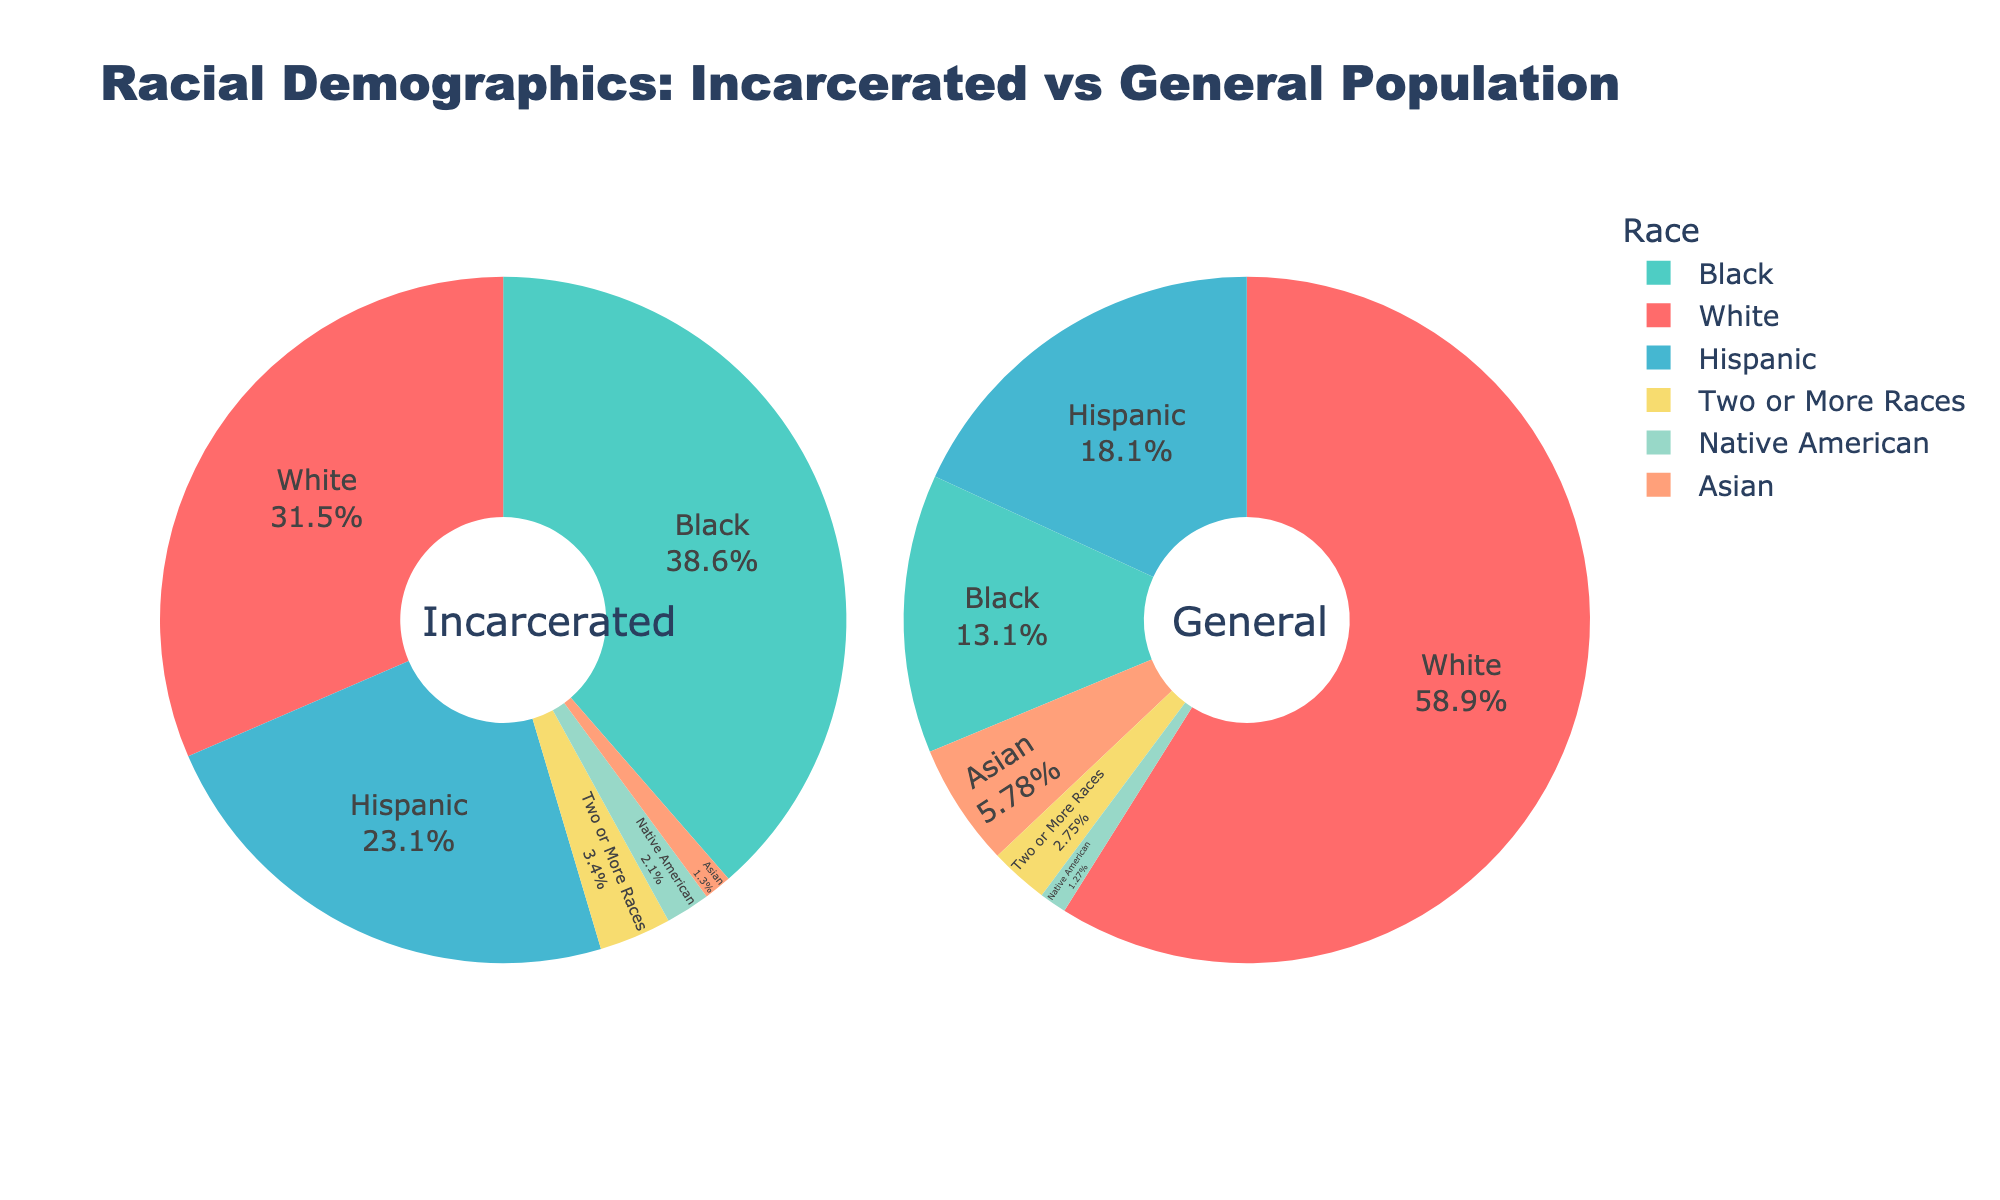Incarcerated Population which racial group has the highest percentage? Observing the pie chart of the Incarcerated Population, the Black racial group's segment occupies the largest area.
Answer: Black Incarcerated Population vs General Population, which race is most overrepresented in incarceration? By comparing the two pie charts, the Black racial group is significantly larger in the Incarcerated Population chart (38.6%) compared to its representation in the General Population (13.4%).
Answer: Black What's the overall difference in representation between the White racial group in the General Population and Incarcerated Population? Subtracting the percentage of the White racial group in the Incarcerated Population (31.5%) from their percentage in the General Population (60.1%) gives 28.6%.
Answer: 28.6% What is the sum of the percentages of Hispanic and Asian groups in the Incarcerated Population? Adding the percentage of the Hispanic group (23.1%) with the percentage of the Asian group (1.3%) in the Incarcerated Population chart results in 24.4%.
Answer: 24.4% How many racial groups have a higher percentage in the General Population than in the Incarcerated Population? Comparing both charts, White (60.1% > 31.5%), Asian (5.9% > 1.3%), and Two or More Races (2.8% > 3.4%) all have higher percentages in the General Population than in the Incarcerated Population. Hence, three racial groups.
Answer: Three Which racial group has the smallest difference in representation between the General Population and Incarcerated Population? Native American group: subtracting their percentage in the Incarcerated Population (2.1%) from their percentage in the General Population (1.3%) gives 0.8%, which is the smallest difference among all groups.
Answer: Native American If all incarcerated racial groups had the same percentage as their representation in the General Population, what would be the percentage of the Hispanic group? The Hispanic group would represent 18.5%, the same as their percentage in the General Population.
Answer: 18.5% Which color represents the Two or More Races segment in the General Population chart? Observing the colors in the pie charts, the segment for Two or More Races in the General Population chart is represented by yellow.
Answer: Yellow 